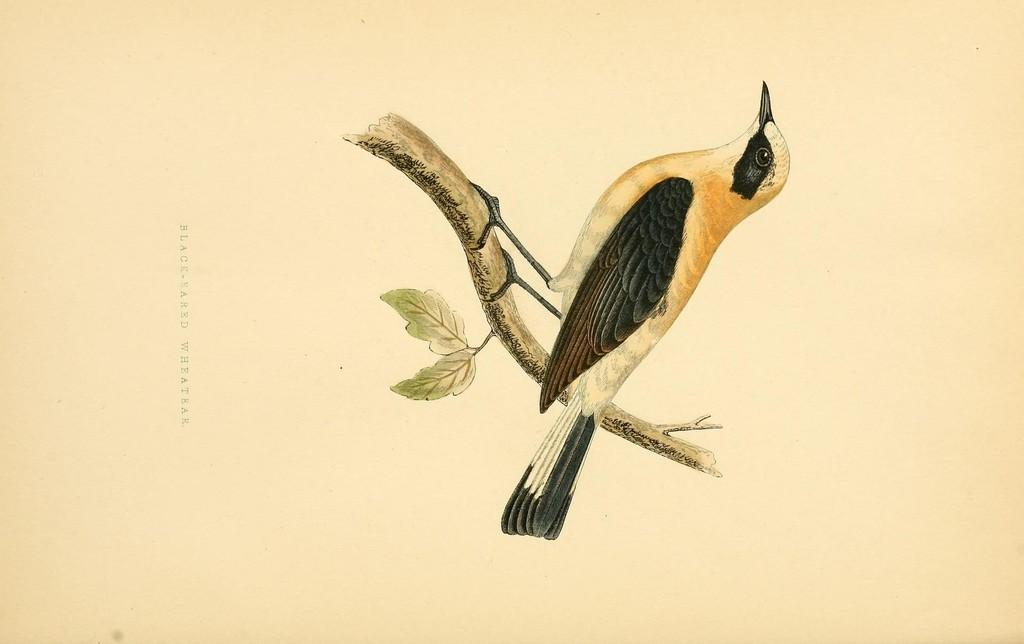What type of animal is in the image? There is a bird in the image. Where is the bird located? The bird is on a branch of a tree. What can be seen in the background of the image? There are leaves in the image. What is the poster with text in the image used for? The purpose of the poster with text is not specified in the image, but it is present. What type of sock is the bird wearing in the image? There is no sock present in the image, as birds do not wear clothing. 